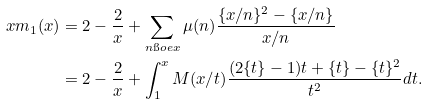Convert formula to latex. <formula><loc_0><loc_0><loc_500><loc_500>x m _ { 1 } ( x ) & = 2 - \frac { 2 } { x } + \sum _ { n \i o e x } \mu ( n ) \frac { \{ x / n \} ^ { 2 } - \{ x / n \} } { x / n } \\ & = 2 - \frac { 2 } { x } + \int _ { 1 } ^ { x } M ( x / t ) \frac { ( 2 \{ t \} - 1 ) t + \{ t \} - \{ t \} ^ { 2 } } { t ^ { 2 } } d t .</formula> 